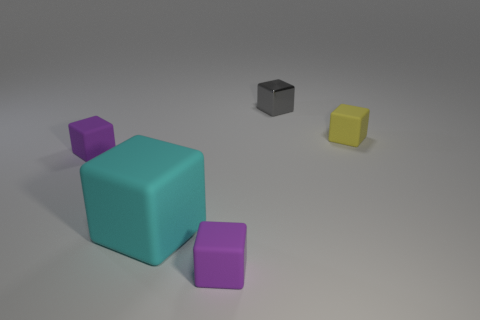Are there fewer metal objects left of the cyan rubber object than big rubber blocks?
Your answer should be very brief. Yes. The rubber cube that is both on the right side of the big cyan thing and behind the large cyan matte cube is what color?
Your response must be concise. Yellow. What number of other things are the same shape as the tiny shiny object?
Your answer should be very brief. 4. Is the number of gray blocks to the left of the large object less than the number of objects on the left side of the tiny yellow cube?
Provide a succinct answer. Yes. Are the cyan object and the tiny yellow block that is on the right side of the big cube made of the same material?
Give a very brief answer. Yes. Are there any other things that have the same material as the yellow cube?
Your answer should be very brief. Yes. Are there more large cyan blocks than purple matte things?
Provide a short and direct response. No. The object that is right of the tiny thing that is behind the small cube right of the small metal block is what shape?
Your answer should be compact. Cube. Is the tiny purple object that is left of the large thing made of the same material as the tiny block right of the metallic thing?
Offer a terse response. Yes. What is the shape of the yellow thing that is the same material as the cyan object?
Offer a terse response. Cube. 